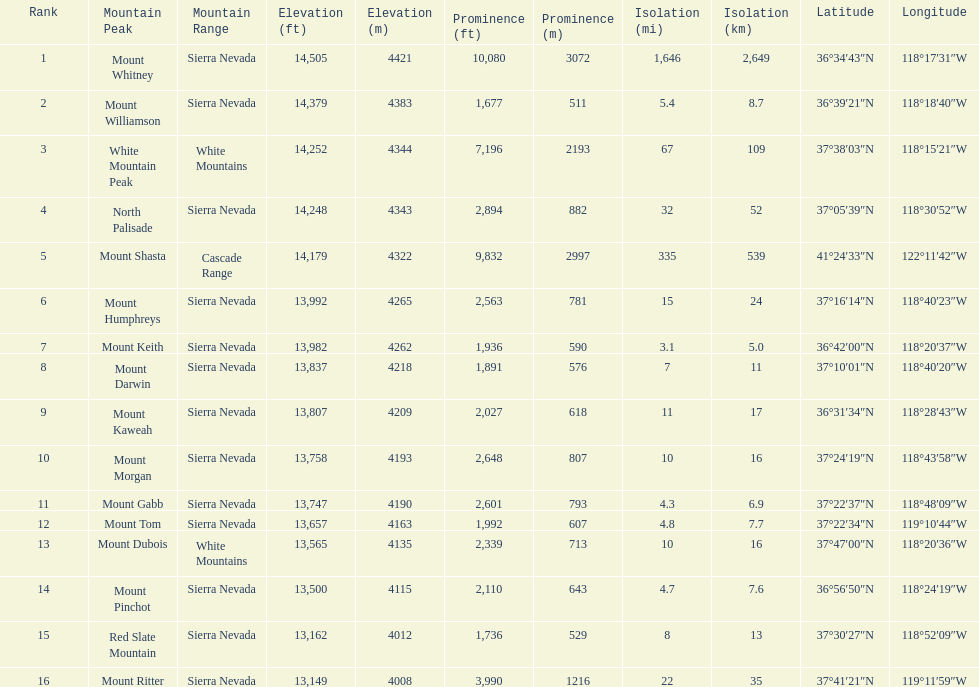In feet, what is the difference between the tallest peak and the 9th tallest peak in california? 698 ft. 